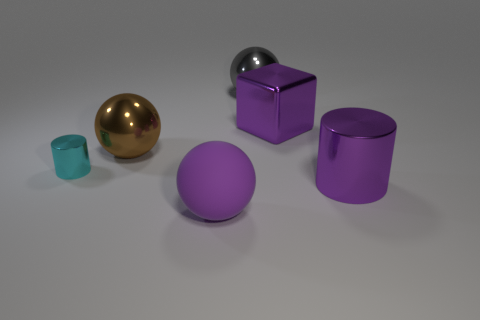Is the shape of the big purple matte object that is in front of the cyan thing the same as the gray object that is to the right of the cyan metal cylinder?
Your answer should be very brief. Yes. There is a brown shiny thing that is the same shape as the matte object; what is its size?
Your answer should be very brief. Large. Is there any other thing that is the same size as the cyan cylinder?
Keep it short and to the point. No. What number of other objects are there of the same color as the metallic block?
Your response must be concise. 2. What number of blocks are big brown metal things or big purple metal things?
Provide a short and direct response. 1. What color is the metal cylinder to the left of the purple metallic thing that is right of the purple metallic cube?
Give a very brief answer. Cyan. What shape is the big gray object?
Your answer should be very brief. Sphere. Is the size of the cylinder on the left side of the gray ball the same as the big purple sphere?
Give a very brief answer. No. Is there a red cylinder made of the same material as the large purple ball?
Your answer should be very brief. No. How many objects are things left of the big purple metal cylinder or large purple matte spheres?
Provide a short and direct response. 5. 